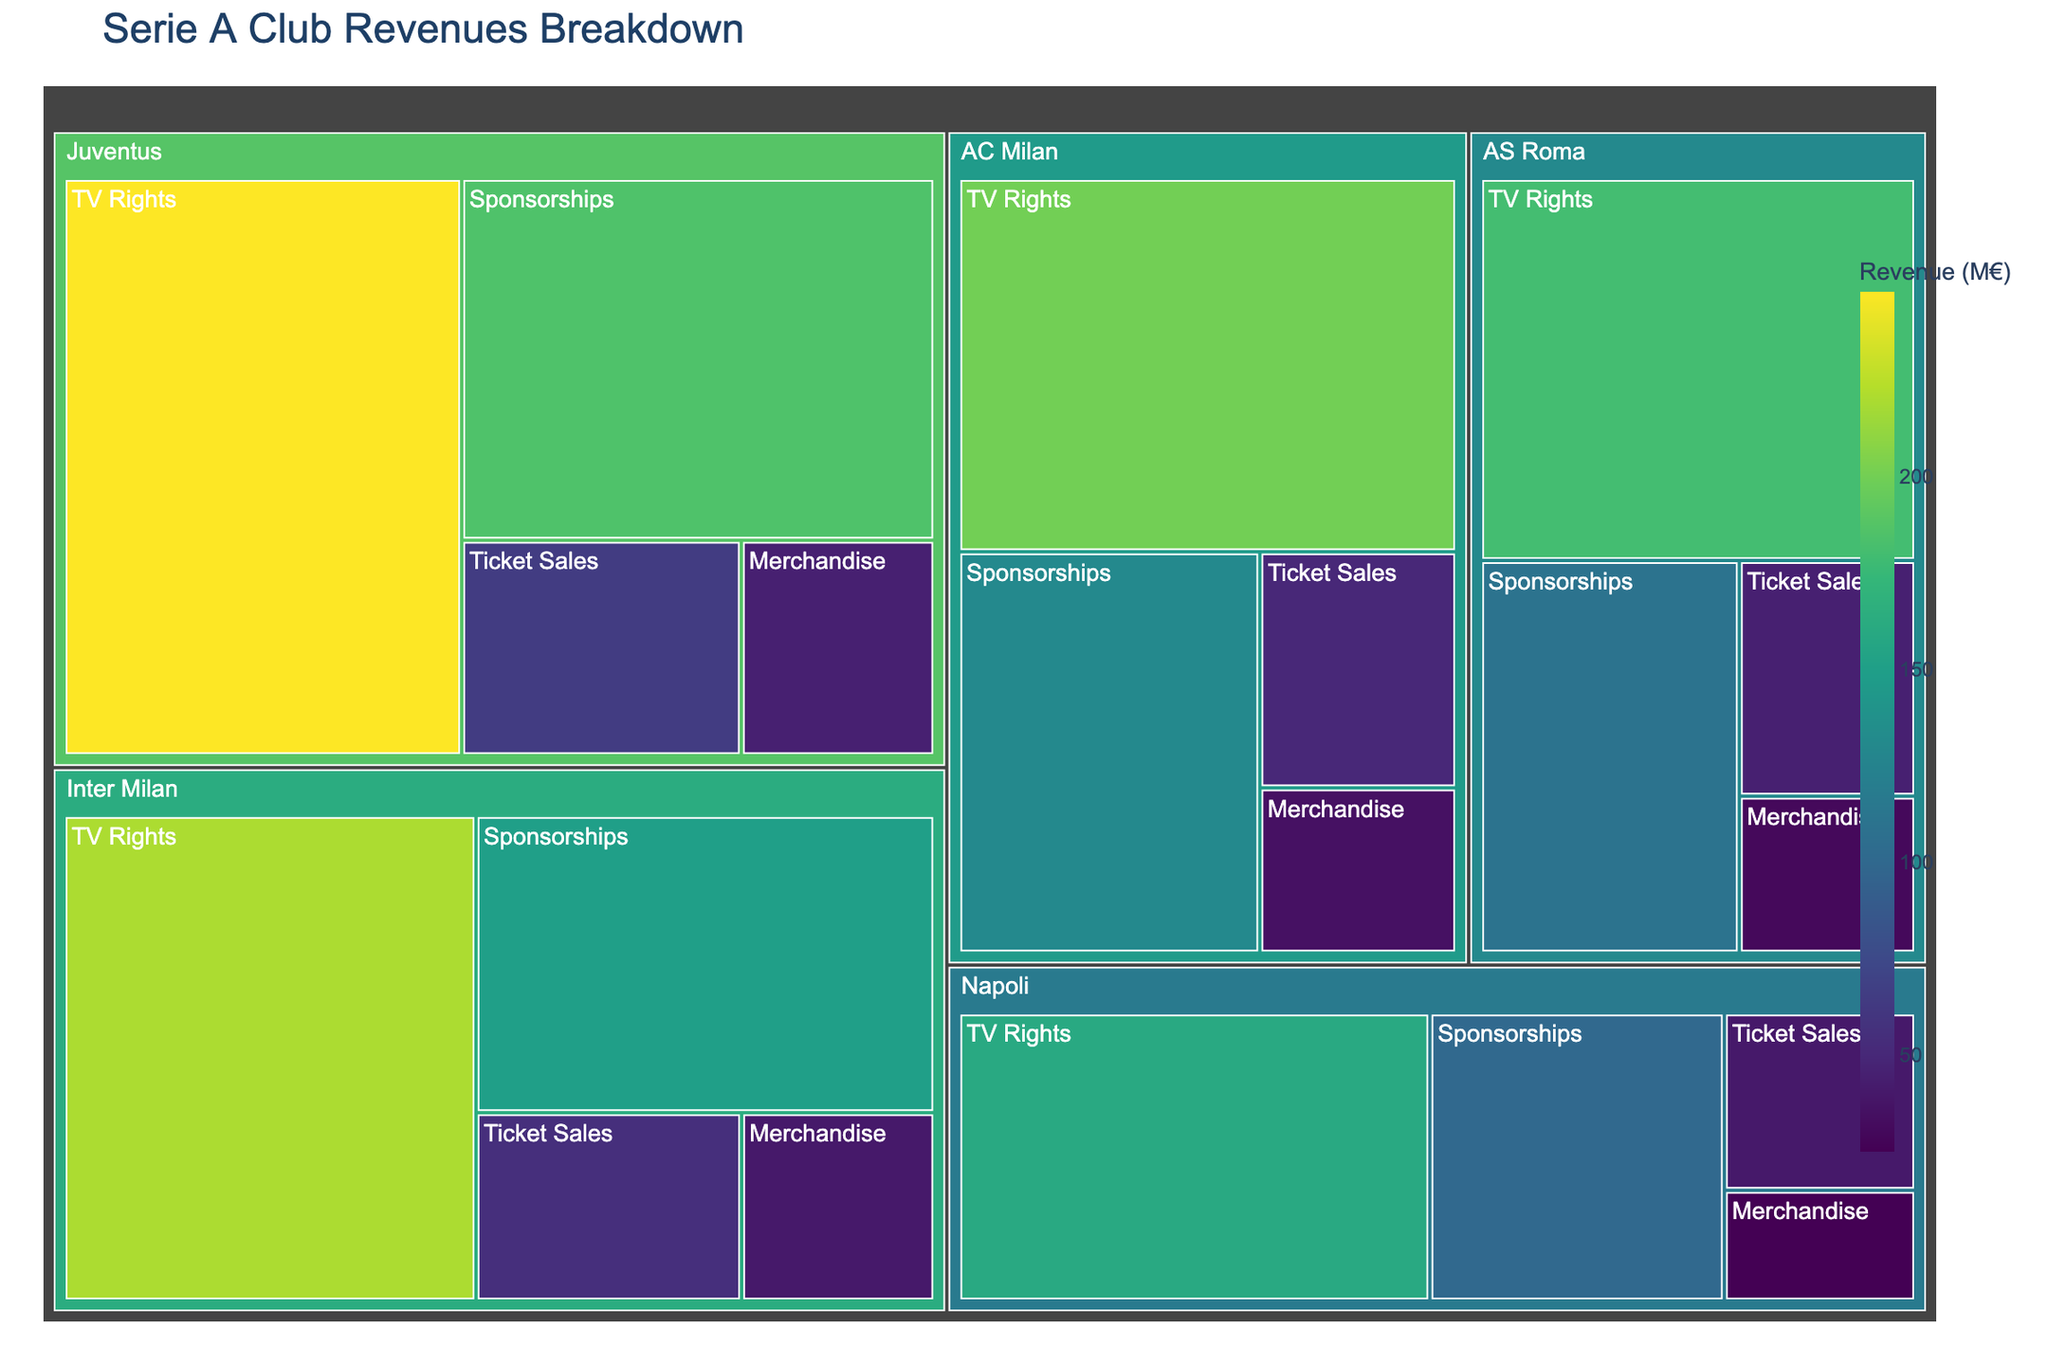How many clubs are included in the Serie A club revenues breakdown? By looking at the Treemap, we can count the distinct club names presented in the plot, namely Juventus, Inter Milan, AC Milan, AS Roma, and Napoli.
Answer: 5 Which club generates the highest total revenue from all sources combined? The club with the largest area in the Treemap indicates the highest total revenue. Juventus has the largest area, suggesting it generates the highest total revenue.
Answer: Juventus How much revenue does Juventus earn from TV rights? Referring to the segment labeled "TV Rights" under Juventus, the revenue amount is displayed directly.
Answer: €248M What is the difference in ticket sales revenue between Inter Milan and AC Milan? We look at the "Ticket Sales" segment for both Inter Milan and AC Milan. Inter Milan earns €55M and AC Milan earns €50M. The difference is €55M - €50M.
Answer: €5M Which category contributes the least to AC Milan's total revenue? By examining the smallest segment under AC Milan, we can see that Merchandise is the smallest, contributing the least to AC Milan's total revenue.
Answer: Merchandise What is the combined sponsorship revenue for all clubs? To get this, we sum up the Sponsorships revenue for all clubs: Juventus (€185M) + Inter Milan (€150M) + AC Milan (€130M) + AS Roma (€110M) + Napoli (€100M).
Answer: €675M Which club has the highest revenue from merchandising? By identifying the largest Merchandise segment within the Treemap, we find that Juventus, with €45M, has the highest merchandising revenue.
Answer: Juventus What is the average TV rights revenue across all clubs? We sum the TV rights revenue for all clubs (Juventus: €248M, Inter Milan: €220M, AC Milan: €200M, AS Roma: €180M, Napoli: €160M) and divide by the number of clubs. Total is €1008M, and with 5 clubs, the average is €1008M / 5.
Answer: €201.6M Compare the total revenues from ticket sales and merchandise for Inter Milan. Which is higher? Inter Milan's revenue from Ticket Sales is €55M and from Merchandise is €40M. Ticket Sales (€55M) is higher than Merchandise (€40M).
Answer: Ticket Sales What is the proportional share of Napoli's TV rights revenue compared to its total revenue? First, calculate Napoli's total revenue: TV Rights (€160M) + Sponsorships (€100M) + Ticket Sales (€40M) + Merchandise (€25M) = €325M. The proportion of TV Rights is (€160M / €325M).
Answer: 49.23% 